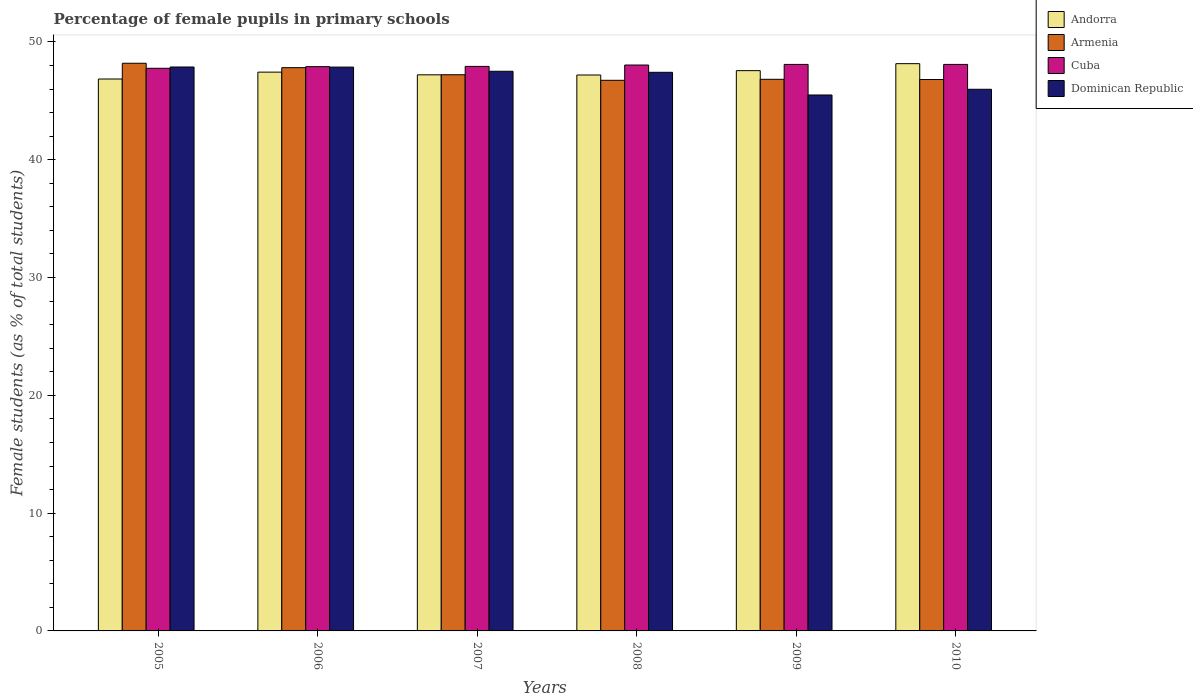How many groups of bars are there?
Provide a short and direct response. 6. How many bars are there on the 4th tick from the left?
Make the answer very short. 4. How many bars are there on the 6th tick from the right?
Make the answer very short. 4. What is the percentage of female pupils in primary schools in Armenia in 2009?
Your response must be concise. 46.83. Across all years, what is the maximum percentage of female pupils in primary schools in Cuba?
Provide a short and direct response. 48.09. Across all years, what is the minimum percentage of female pupils in primary schools in Andorra?
Provide a short and direct response. 46.85. In which year was the percentage of female pupils in primary schools in Dominican Republic maximum?
Ensure brevity in your answer.  2005. What is the total percentage of female pupils in primary schools in Dominican Republic in the graph?
Your answer should be compact. 282.16. What is the difference between the percentage of female pupils in primary schools in Armenia in 2008 and that in 2010?
Your answer should be compact. -0.07. What is the difference between the percentage of female pupils in primary schools in Andorra in 2007 and the percentage of female pupils in primary schools in Armenia in 2010?
Keep it short and to the point. 0.4. What is the average percentage of female pupils in primary schools in Cuba per year?
Keep it short and to the point. 47.97. In the year 2005, what is the difference between the percentage of female pupils in primary schools in Andorra and percentage of female pupils in primary schools in Armenia?
Ensure brevity in your answer.  -1.34. What is the ratio of the percentage of female pupils in primary schools in Andorra in 2007 to that in 2008?
Provide a succinct answer. 1. Is the difference between the percentage of female pupils in primary schools in Andorra in 2008 and 2009 greater than the difference between the percentage of female pupils in primary schools in Armenia in 2008 and 2009?
Ensure brevity in your answer.  No. What is the difference between the highest and the second highest percentage of female pupils in primary schools in Andorra?
Your answer should be compact. 0.59. What is the difference between the highest and the lowest percentage of female pupils in primary schools in Armenia?
Your response must be concise. 1.45. Is it the case that in every year, the sum of the percentage of female pupils in primary schools in Armenia and percentage of female pupils in primary schools in Dominican Republic is greater than the sum of percentage of female pupils in primary schools in Andorra and percentage of female pupils in primary schools in Cuba?
Make the answer very short. No. What does the 4th bar from the left in 2005 represents?
Ensure brevity in your answer.  Dominican Republic. What does the 4th bar from the right in 2010 represents?
Your response must be concise. Andorra. Is it the case that in every year, the sum of the percentage of female pupils in primary schools in Cuba and percentage of female pupils in primary schools in Andorra is greater than the percentage of female pupils in primary schools in Armenia?
Offer a terse response. Yes. How many bars are there?
Your response must be concise. 24. Are all the bars in the graph horizontal?
Ensure brevity in your answer.  No. What is the difference between two consecutive major ticks on the Y-axis?
Give a very brief answer. 10. Are the values on the major ticks of Y-axis written in scientific E-notation?
Your answer should be compact. No. Does the graph contain grids?
Your response must be concise. No. How are the legend labels stacked?
Make the answer very short. Vertical. What is the title of the graph?
Your response must be concise. Percentage of female pupils in primary schools. Does "East Asia (developing only)" appear as one of the legend labels in the graph?
Your answer should be very brief. No. What is the label or title of the Y-axis?
Keep it short and to the point. Female students (as % of total students). What is the Female students (as % of total students) in Andorra in 2005?
Ensure brevity in your answer.  46.85. What is the Female students (as % of total students) of Armenia in 2005?
Offer a very short reply. 48.19. What is the Female students (as % of total students) in Cuba in 2005?
Offer a terse response. 47.76. What is the Female students (as % of total students) of Dominican Republic in 2005?
Provide a short and direct response. 47.87. What is the Female students (as % of total students) in Andorra in 2006?
Provide a short and direct response. 47.44. What is the Female students (as % of total students) of Armenia in 2006?
Keep it short and to the point. 47.82. What is the Female students (as % of total students) in Cuba in 2006?
Make the answer very short. 47.9. What is the Female students (as % of total students) in Dominican Republic in 2006?
Make the answer very short. 47.87. What is the Female students (as % of total students) in Andorra in 2007?
Offer a very short reply. 47.21. What is the Female students (as % of total students) of Armenia in 2007?
Make the answer very short. 47.22. What is the Female students (as % of total students) in Cuba in 2007?
Provide a short and direct response. 47.92. What is the Female students (as % of total students) of Dominican Republic in 2007?
Give a very brief answer. 47.51. What is the Female students (as % of total students) in Andorra in 2008?
Your answer should be very brief. 47.2. What is the Female students (as % of total students) of Armenia in 2008?
Give a very brief answer. 46.74. What is the Female students (as % of total students) in Cuba in 2008?
Provide a succinct answer. 48.04. What is the Female students (as % of total students) in Dominican Republic in 2008?
Provide a succinct answer. 47.42. What is the Female students (as % of total students) of Andorra in 2009?
Offer a very short reply. 47.56. What is the Female students (as % of total students) in Armenia in 2009?
Give a very brief answer. 46.83. What is the Female students (as % of total students) of Cuba in 2009?
Make the answer very short. 48.09. What is the Female students (as % of total students) in Dominican Republic in 2009?
Your response must be concise. 45.5. What is the Female students (as % of total students) in Andorra in 2010?
Your answer should be very brief. 48.16. What is the Female students (as % of total students) of Armenia in 2010?
Provide a short and direct response. 46.81. What is the Female students (as % of total students) in Cuba in 2010?
Your answer should be very brief. 48.09. What is the Female students (as % of total students) in Dominican Republic in 2010?
Provide a short and direct response. 45.98. Across all years, what is the maximum Female students (as % of total students) in Andorra?
Ensure brevity in your answer.  48.16. Across all years, what is the maximum Female students (as % of total students) of Armenia?
Offer a terse response. 48.19. Across all years, what is the maximum Female students (as % of total students) of Cuba?
Give a very brief answer. 48.09. Across all years, what is the maximum Female students (as % of total students) of Dominican Republic?
Make the answer very short. 47.87. Across all years, what is the minimum Female students (as % of total students) in Andorra?
Keep it short and to the point. 46.85. Across all years, what is the minimum Female students (as % of total students) in Armenia?
Provide a succinct answer. 46.74. Across all years, what is the minimum Female students (as % of total students) in Cuba?
Ensure brevity in your answer.  47.76. Across all years, what is the minimum Female students (as % of total students) of Dominican Republic?
Keep it short and to the point. 45.5. What is the total Female students (as % of total students) of Andorra in the graph?
Your response must be concise. 284.42. What is the total Female students (as % of total students) of Armenia in the graph?
Offer a very short reply. 283.61. What is the total Female students (as % of total students) in Cuba in the graph?
Provide a succinct answer. 287.82. What is the total Female students (as % of total students) in Dominican Republic in the graph?
Your answer should be very brief. 282.16. What is the difference between the Female students (as % of total students) in Andorra in 2005 and that in 2006?
Ensure brevity in your answer.  -0.58. What is the difference between the Female students (as % of total students) in Armenia in 2005 and that in 2006?
Your answer should be compact. 0.37. What is the difference between the Female students (as % of total students) in Cuba in 2005 and that in 2006?
Keep it short and to the point. -0.14. What is the difference between the Female students (as % of total students) in Dominican Republic in 2005 and that in 2006?
Ensure brevity in your answer.  0.01. What is the difference between the Female students (as % of total students) of Andorra in 2005 and that in 2007?
Provide a succinct answer. -0.36. What is the difference between the Female students (as % of total students) in Armenia in 2005 and that in 2007?
Offer a very short reply. 0.98. What is the difference between the Female students (as % of total students) of Cuba in 2005 and that in 2007?
Provide a short and direct response. -0.16. What is the difference between the Female students (as % of total students) of Dominican Republic in 2005 and that in 2007?
Ensure brevity in your answer.  0.36. What is the difference between the Female students (as % of total students) of Andorra in 2005 and that in 2008?
Your response must be concise. -0.34. What is the difference between the Female students (as % of total students) of Armenia in 2005 and that in 2008?
Keep it short and to the point. 1.45. What is the difference between the Female students (as % of total students) of Cuba in 2005 and that in 2008?
Make the answer very short. -0.28. What is the difference between the Female students (as % of total students) in Dominican Republic in 2005 and that in 2008?
Your response must be concise. 0.45. What is the difference between the Female students (as % of total students) in Andorra in 2005 and that in 2009?
Provide a short and direct response. -0.71. What is the difference between the Female students (as % of total students) in Armenia in 2005 and that in 2009?
Make the answer very short. 1.36. What is the difference between the Female students (as % of total students) of Cuba in 2005 and that in 2009?
Provide a short and direct response. -0.33. What is the difference between the Female students (as % of total students) of Dominican Republic in 2005 and that in 2009?
Your response must be concise. 2.38. What is the difference between the Female students (as % of total students) of Andorra in 2005 and that in 2010?
Give a very brief answer. -1.3. What is the difference between the Female students (as % of total students) in Armenia in 2005 and that in 2010?
Your response must be concise. 1.38. What is the difference between the Female students (as % of total students) in Cuba in 2005 and that in 2010?
Give a very brief answer. -0.33. What is the difference between the Female students (as % of total students) of Dominican Republic in 2005 and that in 2010?
Keep it short and to the point. 1.89. What is the difference between the Female students (as % of total students) in Andorra in 2006 and that in 2007?
Offer a very short reply. 0.23. What is the difference between the Female students (as % of total students) in Armenia in 2006 and that in 2007?
Keep it short and to the point. 0.6. What is the difference between the Female students (as % of total students) in Cuba in 2006 and that in 2007?
Provide a succinct answer. -0.02. What is the difference between the Female students (as % of total students) in Dominican Republic in 2006 and that in 2007?
Offer a very short reply. 0.35. What is the difference between the Female students (as % of total students) in Andorra in 2006 and that in 2008?
Your response must be concise. 0.24. What is the difference between the Female students (as % of total students) of Armenia in 2006 and that in 2008?
Offer a very short reply. 1.07. What is the difference between the Female students (as % of total students) of Cuba in 2006 and that in 2008?
Offer a terse response. -0.14. What is the difference between the Female students (as % of total students) of Dominican Republic in 2006 and that in 2008?
Your response must be concise. 0.44. What is the difference between the Female students (as % of total students) of Andorra in 2006 and that in 2009?
Provide a succinct answer. -0.13. What is the difference between the Female students (as % of total students) of Armenia in 2006 and that in 2009?
Your response must be concise. 0.99. What is the difference between the Female students (as % of total students) in Cuba in 2006 and that in 2009?
Provide a succinct answer. -0.19. What is the difference between the Female students (as % of total students) of Dominican Republic in 2006 and that in 2009?
Provide a succinct answer. 2.37. What is the difference between the Female students (as % of total students) in Andorra in 2006 and that in 2010?
Your response must be concise. -0.72. What is the difference between the Female students (as % of total students) in Cuba in 2006 and that in 2010?
Make the answer very short. -0.19. What is the difference between the Female students (as % of total students) of Dominican Republic in 2006 and that in 2010?
Offer a terse response. 1.88. What is the difference between the Female students (as % of total students) in Andorra in 2007 and that in 2008?
Make the answer very short. 0.02. What is the difference between the Female students (as % of total students) in Armenia in 2007 and that in 2008?
Make the answer very short. 0.47. What is the difference between the Female students (as % of total students) in Cuba in 2007 and that in 2008?
Your answer should be very brief. -0.12. What is the difference between the Female students (as % of total students) of Dominican Republic in 2007 and that in 2008?
Your response must be concise. 0.09. What is the difference between the Female students (as % of total students) of Andorra in 2007 and that in 2009?
Your response must be concise. -0.35. What is the difference between the Female students (as % of total students) of Armenia in 2007 and that in 2009?
Ensure brevity in your answer.  0.39. What is the difference between the Female students (as % of total students) of Cuba in 2007 and that in 2009?
Give a very brief answer. -0.17. What is the difference between the Female students (as % of total students) of Dominican Republic in 2007 and that in 2009?
Keep it short and to the point. 2.01. What is the difference between the Female students (as % of total students) in Andorra in 2007 and that in 2010?
Keep it short and to the point. -0.95. What is the difference between the Female students (as % of total students) of Armenia in 2007 and that in 2010?
Provide a short and direct response. 0.4. What is the difference between the Female students (as % of total students) in Cuba in 2007 and that in 2010?
Offer a very short reply. -0.17. What is the difference between the Female students (as % of total students) in Dominican Republic in 2007 and that in 2010?
Keep it short and to the point. 1.53. What is the difference between the Female students (as % of total students) in Andorra in 2008 and that in 2009?
Keep it short and to the point. -0.37. What is the difference between the Female students (as % of total students) in Armenia in 2008 and that in 2009?
Your answer should be very brief. -0.09. What is the difference between the Female students (as % of total students) of Cuba in 2008 and that in 2009?
Give a very brief answer. -0.05. What is the difference between the Female students (as % of total students) in Dominican Republic in 2008 and that in 2009?
Offer a very short reply. 1.93. What is the difference between the Female students (as % of total students) of Andorra in 2008 and that in 2010?
Your answer should be very brief. -0.96. What is the difference between the Female students (as % of total students) in Armenia in 2008 and that in 2010?
Ensure brevity in your answer.  -0.07. What is the difference between the Female students (as % of total students) in Cuba in 2008 and that in 2010?
Your response must be concise. -0.05. What is the difference between the Female students (as % of total students) of Dominican Republic in 2008 and that in 2010?
Ensure brevity in your answer.  1.44. What is the difference between the Female students (as % of total students) of Andorra in 2009 and that in 2010?
Give a very brief answer. -0.59. What is the difference between the Female students (as % of total students) in Armenia in 2009 and that in 2010?
Offer a very short reply. 0.02. What is the difference between the Female students (as % of total students) in Dominican Republic in 2009 and that in 2010?
Offer a very short reply. -0.48. What is the difference between the Female students (as % of total students) of Andorra in 2005 and the Female students (as % of total students) of Armenia in 2006?
Your answer should be compact. -0.96. What is the difference between the Female students (as % of total students) in Andorra in 2005 and the Female students (as % of total students) in Cuba in 2006?
Offer a terse response. -1.05. What is the difference between the Female students (as % of total students) of Andorra in 2005 and the Female students (as % of total students) of Dominican Republic in 2006?
Ensure brevity in your answer.  -1.01. What is the difference between the Female students (as % of total students) in Armenia in 2005 and the Female students (as % of total students) in Cuba in 2006?
Give a very brief answer. 0.29. What is the difference between the Female students (as % of total students) of Armenia in 2005 and the Female students (as % of total students) of Dominican Republic in 2006?
Give a very brief answer. 0.33. What is the difference between the Female students (as % of total students) of Cuba in 2005 and the Female students (as % of total students) of Dominican Republic in 2006?
Ensure brevity in your answer.  -0.1. What is the difference between the Female students (as % of total students) of Andorra in 2005 and the Female students (as % of total students) of Armenia in 2007?
Make the answer very short. -0.36. What is the difference between the Female students (as % of total students) in Andorra in 2005 and the Female students (as % of total students) in Cuba in 2007?
Make the answer very short. -1.07. What is the difference between the Female students (as % of total students) in Andorra in 2005 and the Female students (as % of total students) in Dominican Republic in 2007?
Ensure brevity in your answer.  -0.66. What is the difference between the Female students (as % of total students) of Armenia in 2005 and the Female students (as % of total students) of Cuba in 2007?
Your response must be concise. 0.27. What is the difference between the Female students (as % of total students) in Armenia in 2005 and the Female students (as % of total students) in Dominican Republic in 2007?
Keep it short and to the point. 0.68. What is the difference between the Female students (as % of total students) of Cuba in 2005 and the Female students (as % of total students) of Dominican Republic in 2007?
Make the answer very short. 0.25. What is the difference between the Female students (as % of total students) of Andorra in 2005 and the Female students (as % of total students) of Armenia in 2008?
Your response must be concise. 0.11. What is the difference between the Female students (as % of total students) in Andorra in 2005 and the Female students (as % of total students) in Cuba in 2008?
Provide a short and direct response. -1.19. What is the difference between the Female students (as % of total students) in Andorra in 2005 and the Female students (as % of total students) in Dominican Republic in 2008?
Your answer should be very brief. -0.57. What is the difference between the Female students (as % of total students) in Armenia in 2005 and the Female students (as % of total students) in Cuba in 2008?
Ensure brevity in your answer.  0.15. What is the difference between the Female students (as % of total students) in Armenia in 2005 and the Female students (as % of total students) in Dominican Republic in 2008?
Your answer should be compact. 0.77. What is the difference between the Female students (as % of total students) in Cuba in 2005 and the Female students (as % of total students) in Dominican Republic in 2008?
Provide a succinct answer. 0.34. What is the difference between the Female students (as % of total students) of Andorra in 2005 and the Female students (as % of total students) of Armenia in 2009?
Your answer should be compact. 0.02. What is the difference between the Female students (as % of total students) in Andorra in 2005 and the Female students (as % of total students) in Cuba in 2009?
Your answer should be compact. -1.24. What is the difference between the Female students (as % of total students) in Andorra in 2005 and the Female students (as % of total students) in Dominican Republic in 2009?
Offer a terse response. 1.36. What is the difference between the Female students (as % of total students) in Armenia in 2005 and the Female students (as % of total students) in Cuba in 2009?
Give a very brief answer. 0.1. What is the difference between the Female students (as % of total students) in Armenia in 2005 and the Female students (as % of total students) in Dominican Republic in 2009?
Your answer should be very brief. 2.69. What is the difference between the Female students (as % of total students) in Cuba in 2005 and the Female students (as % of total students) in Dominican Republic in 2009?
Give a very brief answer. 2.27. What is the difference between the Female students (as % of total students) of Andorra in 2005 and the Female students (as % of total students) of Armenia in 2010?
Ensure brevity in your answer.  0.04. What is the difference between the Female students (as % of total students) in Andorra in 2005 and the Female students (as % of total students) in Cuba in 2010?
Provide a short and direct response. -1.24. What is the difference between the Female students (as % of total students) in Andorra in 2005 and the Female students (as % of total students) in Dominican Republic in 2010?
Ensure brevity in your answer.  0.87. What is the difference between the Female students (as % of total students) of Armenia in 2005 and the Female students (as % of total students) of Cuba in 2010?
Your answer should be very brief. 0.1. What is the difference between the Female students (as % of total students) in Armenia in 2005 and the Female students (as % of total students) in Dominican Republic in 2010?
Offer a very short reply. 2.21. What is the difference between the Female students (as % of total students) in Cuba in 2005 and the Female students (as % of total students) in Dominican Republic in 2010?
Offer a very short reply. 1.78. What is the difference between the Female students (as % of total students) in Andorra in 2006 and the Female students (as % of total students) in Armenia in 2007?
Your answer should be compact. 0.22. What is the difference between the Female students (as % of total students) of Andorra in 2006 and the Female students (as % of total students) of Cuba in 2007?
Your response must be concise. -0.49. What is the difference between the Female students (as % of total students) in Andorra in 2006 and the Female students (as % of total students) in Dominican Republic in 2007?
Give a very brief answer. -0.07. What is the difference between the Female students (as % of total students) in Armenia in 2006 and the Female students (as % of total students) in Cuba in 2007?
Your answer should be very brief. -0.11. What is the difference between the Female students (as % of total students) of Armenia in 2006 and the Female students (as % of total students) of Dominican Republic in 2007?
Make the answer very short. 0.31. What is the difference between the Female students (as % of total students) of Cuba in 2006 and the Female students (as % of total students) of Dominican Republic in 2007?
Your answer should be compact. 0.39. What is the difference between the Female students (as % of total students) in Andorra in 2006 and the Female students (as % of total students) in Armenia in 2008?
Your response must be concise. 0.69. What is the difference between the Female students (as % of total students) of Andorra in 2006 and the Female students (as % of total students) of Cuba in 2008?
Make the answer very short. -0.6. What is the difference between the Female students (as % of total students) of Andorra in 2006 and the Female students (as % of total students) of Dominican Republic in 2008?
Provide a short and direct response. 0.01. What is the difference between the Female students (as % of total students) of Armenia in 2006 and the Female students (as % of total students) of Cuba in 2008?
Provide a short and direct response. -0.22. What is the difference between the Female students (as % of total students) of Armenia in 2006 and the Female students (as % of total students) of Dominican Republic in 2008?
Make the answer very short. 0.39. What is the difference between the Female students (as % of total students) of Cuba in 2006 and the Female students (as % of total students) of Dominican Republic in 2008?
Keep it short and to the point. 0.48. What is the difference between the Female students (as % of total students) in Andorra in 2006 and the Female students (as % of total students) in Armenia in 2009?
Provide a short and direct response. 0.61. What is the difference between the Female students (as % of total students) of Andorra in 2006 and the Female students (as % of total students) of Cuba in 2009?
Offer a terse response. -0.66. What is the difference between the Female students (as % of total students) of Andorra in 2006 and the Female students (as % of total students) of Dominican Republic in 2009?
Your answer should be very brief. 1.94. What is the difference between the Female students (as % of total students) of Armenia in 2006 and the Female students (as % of total students) of Cuba in 2009?
Keep it short and to the point. -0.28. What is the difference between the Female students (as % of total students) in Armenia in 2006 and the Female students (as % of total students) in Dominican Republic in 2009?
Provide a short and direct response. 2.32. What is the difference between the Female students (as % of total students) of Cuba in 2006 and the Female students (as % of total students) of Dominican Republic in 2009?
Ensure brevity in your answer.  2.41. What is the difference between the Female students (as % of total students) of Andorra in 2006 and the Female students (as % of total students) of Armenia in 2010?
Offer a terse response. 0.63. What is the difference between the Female students (as % of total students) in Andorra in 2006 and the Female students (as % of total students) in Cuba in 2010?
Make the answer very short. -0.66. What is the difference between the Female students (as % of total students) in Andorra in 2006 and the Female students (as % of total students) in Dominican Republic in 2010?
Your response must be concise. 1.45. What is the difference between the Female students (as % of total students) in Armenia in 2006 and the Female students (as % of total students) in Cuba in 2010?
Keep it short and to the point. -0.28. What is the difference between the Female students (as % of total students) in Armenia in 2006 and the Female students (as % of total students) in Dominican Republic in 2010?
Offer a terse response. 1.83. What is the difference between the Female students (as % of total students) of Cuba in 2006 and the Female students (as % of total students) of Dominican Republic in 2010?
Ensure brevity in your answer.  1.92. What is the difference between the Female students (as % of total students) of Andorra in 2007 and the Female students (as % of total students) of Armenia in 2008?
Make the answer very short. 0.47. What is the difference between the Female students (as % of total students) in Andorra in 2007 and the Female students (as % of total students) in Cuba in 2008?
Your answer should be very brief. -0.83. What is the difference between the Female students (as % of total students) in Andorra in 2007 and the Female students (as % of total students) in Dominican Republic in 2008?
Your answer should be very brief. -0.21. What is the difference between the Female students (as % of total students) in Armenia in 2007 and the Female students (as % of total students) in Cuba in 2008?
Make the answer very short. -0.82. What is the difference between the Female students (as % of total students) of Armenia in 2007 and the Female students (as % of total students) of Dominican Republic in 2008?
Offer a very short reply. -0.21. What is the difference between the Female students (as % of total students) of Cuba in 2007 and the Female students (as % of total students) of Dominican Republic in 2008?
Your response must be concise. 0.5. What is the difference between the Female students (as % of total students) in Andorra in 2007 and the Female students (as % of total students) in Armenia in 2009?
Offer a very short reply. 0.38. What is the difference between the Female students (as % of total students) in Andorra in 2007 and the Female students (as % of total students) in Cuba in 2009?
Provide a short and direct response. -0.88. What is the difference between the Female students (as % of total students) in Andorra in 2007 and the Female students (as % of total students) in Dominican Republic in 2009?
Make the answer very short. 1.71. What is the difference between the Female students (as % of total students) in Armenia in 2007 and the Female students (as % of total students) in Cuba in 2009?
Keep it short and to the point. -0.88. What is the difference between the Female students (as % of total students) of Armenia in 2007 and the Female students (as % of total students) of Dominican Republic in 2009?
Your answer should be compact. 1.72. What is the difference between the Female students (as % of total students) in Cuba in 2007 and the Female students (as % of total students) in Dominican Republic in 2009?
Provide a short and direct response. 2.43. What is the difference between the Female students (as % of total students) in Andorra in 2007 and the Female students (as % of total students) in Armenia in 2010?
Provide a short and direct response. 0.4. What is the difference between the Female students (as % of total students) in Andorra in 2007 and the Female students (as % of total students) in Cuba in 2010?
Offer a terse response. -0.88. What is the difference between the Female students (as % of total students) of Andorra in 2007 and the Female students (as % of total students) of Dominican Republic in 2010?
Offer a very short reply. 1.23. What is the difference between the Female students (as % of total students) in Armenia in 2007 and the Female students (as % of total students) in Cuba in 2010?
Your response must be concise. -0.88. What is the difference between the Female students (as % of total students) in Armenia in 2007 and the Female students (as % of total students) in Dominican Republic in 2010?
Your answer should be very brief. 1.23. What is the difference between the Female students (as % of total students) in Cuba in 2007 and the Female students (as % of total students) in Dominican Republic in 2010?
Your answer should be compact. 1.94. What is the difference between the Female students (as % of total students) in Andorra in 2008 and the Female students (as % of total students) in Armenia in 2009?
Give a very brief answer. 0.37. What is the difference between the Female students (as % of total students) of Andorra in 2008 and the Female students (as % of total students) of Cuba in 2009?
Make the answer very short. -0.9. What is the difference between the Female students (as % of total students) of Andorra in 2008 and the Female students (as % of total students) of Dominican Republic in 2009?
Ensure brevity in your answer.  1.7. What is the difference between the Female students (as % of total students) in Armenia in 2008 and the Female students (as % of total students) in Cuba in 2009?
Your answer should be very brief. -1.35. What is the difference between the Female students (as % of total students) in Armenia in 2008 and the Female students (as % of total students) in Dominican Republic in 2009?
Your answer should be very brief. 1.25. What is the difference between the Female students (as % of total students) of Cuba in 2008 and the Female students (as % of total students) of Dominican Republic in 2009?
Your response must be concise. 2.54. What is the difference between the Female students (as % of total students) in Andorra in 2008 and the Female students (as % of total students) in Armenia in 2010?
Your answer should be compact. 0.38. What is the difference between the Female students (as % of total students) in Andorra in 2008 and the Female students (as % of total students) in Cuba in 2010?
Provide a succinct answer. -0.9. What is the difference between the Female students (as % of total students) in Andorra in 2008 and the Female students (as % of total students) in Dominican Republic in 2010?
Your response must be concise. 1.21. What is the difference between the Female students (as % of total students) in Armenia in 2008 and the Female students (as % of total students) in Cuba in 2010?
Keep it short and to the point. -1.35. What is the difference between the Female students (as % of total students) in Armenia in 2008 and the Female students (as % of total students) in Dominican Republic in 2010?
Provide a short and direct response. 0.76. What is the difference between the Female students (as % of total students) in Cuba in 2008 and the Female students (as % of total students) in Dominican Republic in 2010?
Provide a short and direct response. 2.06. What is the difference between the Female students (as % of total students) in Andorra in 2009 and the Female students (as % of total students) in Armenia in 2010?
Provide a short and direct response. 0.75. What is the difference between the Female students (as % of total students) of Andorra in 2009 and the Female students (as % of total students) of Cuba in 2010?
Make the answer very short. -0.53. What is the difference between the Female students (as % of total students) in Andorra in 2009 and the Female students (as % of total students) in Dominican Republic in 2010?
Keep it short and to the point. 1.58. What is the difference between the Female students (as % of total students) in Armenia in 2009 and the Female students (as % of total students) in Cuba in 2010?
Offer a very short reply. -1.26. What is the difference between the Female students (as % of total students) in Armenia in 2009 and the Female students (as % of total students) in Dominican Republic in 2010?
Keep it short and to the point. 0.85. What is the difference between the Female students (as % of total students) of Cuba in 2009 and the Female students (as % of total students) of Dominican Republic in 2010?
Your response must be concise. 2.11. What is the average Female students (as % of total students) in Andorra per year?
Your answer should be very brief. 47.4. What is the average Female students (as % of total students) in Armenia per year?
Provide a short and direct response. 47.27. What is the average Female students (as % of total students) in Cuba per year?
Your answer should be very brief. 47.97. What is the average Female students (as % of total students) in Dominican Republic per year?
Your answer should be very brief. 47.03. In the year 2005, what is the difference between the Female students (as % of total students) of Andorra and Female students (as % of total students) of Armenia?
Ensure brevity in your answer.  -1.34. In the year 2005, what is the difference between the Female students (as % of total students) of Andorra and Female students (as % of total students) of Cuba?
Make the answer very short. -0.91. In the year 2005, what is the difference between the Female students (as % of total students) in Andorra and Female students (as % of total students) in Dominican Republic?
Provide a succinct answer. -1.02. In the year 2005, what is the difference between the Female students (as % of total students) of Armenia and Female students (as % of total students) of Cuba?
Provide a short and direct response. 0.43. In the year 2005, what is the difference between the Female students (as % of total students) in Armenia and Female students (as % of total students) in Dominican Republic?
Your response must be concise. 0.32. In the year 2005, what is the difference between the Female students (as % of total students) of Cuba and Female students (as % of total students) of Dominican Republic?
Your answer should be very brief. -0.11. In the year 2006, what is the difference between the Female students (as % of total students) in Andorra and Female students (as % of total students) in Armenia?
Make the answer very short. -0.38. In the year 2006, what is the difference between the Female students (as % of total students) in Andorra and Female students (as % of total students) in Cuba?
Give a very brief answer. -0.47. In the year 2006, what is the difference between the Female students (as % of total students) of Andorra and Female students (as % of total students) of Dominican Republic?
Provide a succinct answer. -0.43. In the year 2006, what is the difference between the Female students (as % of total students) of Armenia and Female students (as % of total students) of Cuba?
Your answer should be compact. -0.09. In the year 2006, what is the difference between the Female students (as % of total students) of Armenia and Female students (as % of total students) of Dominican Republic?
Provide a short and direct response. -0.05. In the year 2006, what is the difference between the Female students (as % of total students) of Cuba and Female students (as % of total students) of Dominican Republic?
Give a very brief answer. 0.04. In the year 2007, what is the difference between the Female students (as % of total students) of Andorra and Female students (as % of total students) of Armenia?
Offer a very short reply. -0.01. In the year 2007, what is the difference between the Female students (as % of total students) in Andorra and Female students (as % of total students) in Cuba?
Keep it short and to the point. -0.71. In the year 2007, what is the difference between the Female students (as % of total students) of Andorra and Female students (as % of total students) of Dominican Republic?
Your answer should be very brief. -0.3. In the year 2007, what is the difference between the Female students (as % of total students) in Armenia and Female students (as % of total students) in Cuba?
Provide a succinct answer. -0.71. In the year 2007, what is the difference between the Female students (as % of total students) in Armenia and Female students (as % of total students) in Dominican Republic?
Your answer should be compact. -0.3. In the year 2007, what is the difference between the Female students (as % of total students) in Cuba and Female students (as % of total students) in Dominican Republic?
Provide a short and direct response. 0.41. In the year 2008, what is the difference between the Female students (as % of total students) in Andorra and Female students (as % of total students) in Armenia?
Offer a very short reply. 0.45. In the year 2008, what is the difference between the Female students (as % of total students) of Andorra and Female students (as % of total students) of Cuba?
Give a very brief answer. -0.85. In the year 2008, what is the difference between the Female students (as % of total students) in Andorra and Female students (as % of total students) in Dominican Republic?
Your response must be concise. -0.23. In the year 2008, what is the difference between the Female students (as % of total students) of Armenia and Female students (as % of total students) of Cuba?
Ensure brevity in your answer.  -1.3. In the year 2008, what is the difference between the Female students (as % of total students) in Armenia and Female students (as % of total students) in Dominican Republic?
Provide a short and direct response. -0.68. In the year 2008, what is the difference between the Female students (as % of total students) of Cuba and Female students (as % of total students) of Dominican Republic?
Offer a terse response. 0.62. In the year 2009, what is the difference between the Female students (as % of total students) in Andorra and Female students (as % of total students) in Armenia?
Provide a short and direct response. 0.73. In the year 2009, what is the difference between the Female students (as % of total students) in Andorra and Female students (as % of total students) in Cuba?
Make the answer very short. -0.53. In the year 2009, what is the difference between the Female students (as % of total students) in Andorra and Female students (as % of total students) in Dominican Republic?
Your response must be concise. 2.07. In the year 2009, what is the difference between the Female students (as % of total students) of Armenia and Female students (as % of total students) of Cuba?
Provide a succinct answer. -1.26. In the year 2009, what is the difference between the Female students (as % of total students) in Armenia and Female students (as % of total students) in Dominican Republic?
Provide a short and direct response. 1.33. In the year 2009, what is the difference between the Female students (as % of total students) in Cuba and Female students (as % of total students) in Dominican Republic?
Your answer should be very brief. 2.6. In the year 2010, what is the difference between the Female students (as % of total students) in Andorra and Female students (as % of total students) in Armenia?
Your answer should be very brief. 1.35. In the year 2010, what is the difference between the Female students (as % of total students) of Andorra and Female students (as % of total students) of Cuba?
Offer a terse response. 0.06. In the year 2010, what is the difference between the Female students (as % of total students) of Andorra and Female students (as % of total students) of Dominican Republic?
Keep it short and to the point. 2.17. In the year 2010, what is the difference between the Female students (as % of total students) of Armenia and Female students (as % of total students) of Cuba?
Your answer should be very brief. -1.28. In the year 2010, what is the difference between the Female students (as % of total students) in Armenia and Female students (as % of total students) in Dominican Republic?
Your answer should be compact. 0.83. In the year 2010, what is the difference between the Female students (as % of total students) in Cuba and Female students (as % of total students) in Dominican Republic?
Your answer should be very brief. 2.11. What is the ratio of the Female students (as % of total students) in Andorra in 2005 to that in 2006?
Offer a terse response. 0.99. What is the ratio of the Female students (as % of total students) in Armenia in 2005 to that in 2006?
Your answer should be very brief. 1.01. What is the ratio of the Female students (as % of total students) in Cuba in 2005 to that in 2006?
Provide a short and direct response. 1. What is the ratio of the Female students (as % of total students) in Armenia in 2005 to that in 2007?
Offer a terse response. 1.02. What is the ratio of the Female students (as % of total students) in Dominican Republic in 2005 to that in 2007?
Make the answer very short. 1.01. What is the ratio of the Female students (as % of total students) of Andorra in 2005 to that in 2008?
Provide a succinct answer. 0.99. What is the ratio of the Female students (as % of total students) in Armenia in 2005 to that in 2008?
Your response must be concise. 1.03. What is the ratio of the Female students (as % of total students) in Dominican Republic in 2005 to that in 2008?
Ensure brevity in your answer.  1.01. What is the ratio of the Female students (as % of total students) of Andorra in 2005 to that in 2009?
Keep it short and to the point. 0.99. What is the ratio of the Female students (as % of total students) of Armenia in 2005 to that in 2009?
Keep it short and to the point. 1.03. What is the ratio of the Female students (as % of total students) in Cuba in 2005 to that in 2009?
Make the answer very short. 0.99. What is the ratio of the Female students (as % of total students) of Dominican Republic in 2005 to that in 2009?
Provide a short and direct response. 1.05. What is the ratio of the Female students (as % of total students) of Andorra in 2005 to that in 2010?
Your answer should be compact. 0.97. What is the ratio of the Female students (as % of total students) of Armenia in 2005 to that in 2010?
Provide a succinct answer. 1.03. What is the ratio of the Female students (as % of total students) in Dominican Republic in 2005 to that in 2010?
Keep it short and to the point. 1.04. What is the ratio of the Female students (as % of total students) in Andorra in 2006 to that in 2007?
Keep it short and to the point. 1. What is the ratio of the Female students (as % of total students) of Armenia in 2006 to that in 2007?
Your response must be concise. 1.01. What is the ratio of the Female students (as % of total students) in Dominican Republic in 2006 to that in 2007?
Your answer should be very brief. 1.01. What is the ratio of the Female students (as % of total students) in Cuba in 2006 to that in 2008?
Provide a short and direct response. 1. What is the ratio of the Female students (as % of total students) of Dominican Republic in 2006 to that in 2008?
Offer a very short reply. 1.01. What is the ratio of the Female students (as % of total students) of Andorra in 2006 to that in 2009?
Ensure brevity in your answer.  1. What is the ratio of the Female students (as % of total students) in Armenia in 2006 to that in 2009?
Provide a short and direct response. 1.02. What is the ratio of the Female students (as % of total students) in Dominican Republic in 2006 to that in 2009?
Your response must be concise. 1.05. What is the ratio of the Female students (as % of total students) in Andorra in 2006 to that in 2010?
Offer a very short reply. 0.99. What is the ratio of the Female students (as % of total students) in Armenia in 2006 to that in 2010?
Your response must be concise. 1.02. What is the ratio of the Female students (as % of total students) in Cuba in 2006 to that in 2010?
Keep it short and to the point. 1. What is the ratio of the Female students (as % of total students) in Dominican Republic in 2006 to that in 2010?
Offer a terse response. 1.04. What is the ratio of the Female students (as % of total students) in Armenia in 2007 to that in 2008?
Give a very brief answer. 1.01. What is the ratio of the Female students (as % of total students) of Dominican Republic in 2007 to that in 2008?
Offer a terse response. 1. What is the ratio of the Female students (as % of total students) of Andorra in 2007 to that in 2009?
Your response must be concise. 0.99. What is the ratio of the Female students (as % of total students) of Armenia in 2007 to that in 2009?
Make the answer very short. 1.01. What is the ratio of the Female students (as % of total students) of Cuba in 2007 to that in 2009?
Provide a short and direct response. 1. What is the ratio of the Female students (as % of total students) of Dominican Republic in 2007 to that in 2009?
Offer a very short reply. 1.04. What is the ratio of the Female students (as % of total students) of Andorra in 2007 to that in 2010?
Your response must be concise. 0.98. What is the ratio of the Female students (as % of total students) in Armenia in 2007 to that in 2010?
Your answer should be very brief. 1.01. What is the ratio of the Female students (as % of total students) of Dominican Republic in 2007 to that in 2010?
Ensure brevity in your answer.  1.03. What is the ratio of the Female students (as % of total students) of Dominican Republic in 2008 to that in 2009?
Provide a succinct answer. 1.04. What is the ratio of the Female students (as % of total students) of Armenia in 2008 to that in 2010?
Make the answer very short. 1. What is the ratio of the Female students (as % of total students) of Dominican Republic in 2008 to that in 2010?
Offer a very short reply. 1.03. What is the ratio of the Female students (as % of total students) of Andorra in 2009 to that in 2010?
Keep it short and to the point. 0.99. What is the difference between the highest and the second highest Female students (as % of total students) in Andorra?
Give a very brief answer. 0.59. What is the difference between the highest and the second highest Female students (as % of total students) of Armenia?
Make the answer very short. 0.37. What is the difference between the highest and the second highest Female students (as % of total students) in Dominican Republic?
Offer a very short reply. 0.01. What is the difference between the highest and the lowest Female students (as % of total students) of Andorra?
Your answer should be compact. 1.3. What is the difference between the highest and the lowest Female students (as % of total students) of Armenia?
Your answer should be compact. 1.45. What is the difference between the highest and the lowest Female students (as % of total students) of Cuba?
Offer a terse response. 0.33. What is the difference between the highest and the lowest Female students (as % of total students) in Dominican Republic?
Make the answer very short. 2.38. 